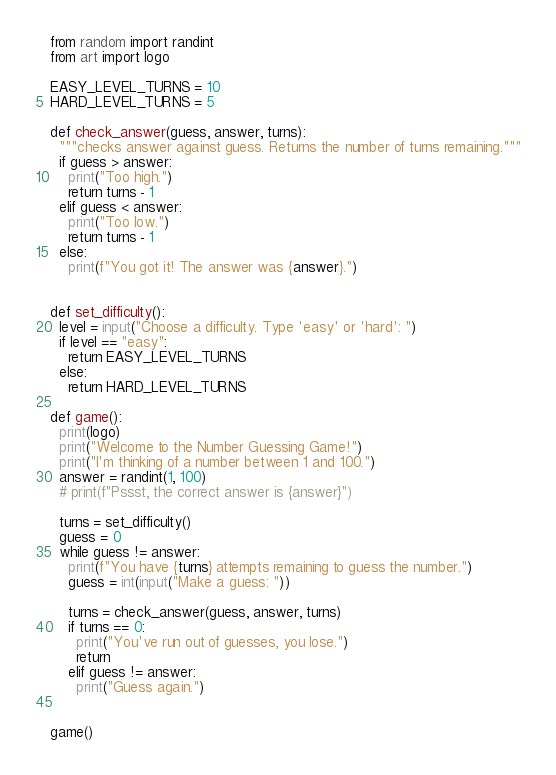Convert code to text. <code><loc_0><loc_0><loc_500><loc_500><_Python_>from random import randint
from art import logo

EASY_LEVEL_TURNS = 10
HARD_LEVEL_TURNS = 5

def check_answer(guess, answer, turns):
  """checks answer against guess. Returns the number of turns remaining."""
  if guess > answer:
    print("Too high.")
    return turns - 1
  elif guess < answer:
    print("Too low.")
    return turns - 1
  else:
    print(f"You got it! The answer was {answer}.")


def set_difficulty():
  level = input("Choose a difficulty. Type 'easy' or 'hard': ")
  if level == "easy":
    return EASY_LEVEL_TURNS
  else:
    return HARD_LEVEL_TURNS

def game():
  print(logo)
  print("Welcome to the Number Guessing Game!")
  print("I'm thinking of a number between 1 and 100.")
  answer = randint(1, 100)
  # print(f"Pssst, the correct answer is {answer}") 

  turns = set_difficulty()
  guess = 0
  while guess != answer:
    print(f"You have {turns} attempts remaining to guess the number.")
    guess = int(input("Make a guess: "))

    turns = check_answer(guess, answer, turns)
    if turns == 0:
      print("You've run out of guesses, you lose.")
      return
    elif guess != answer:
      print("Guess again.")


game()

</code> 